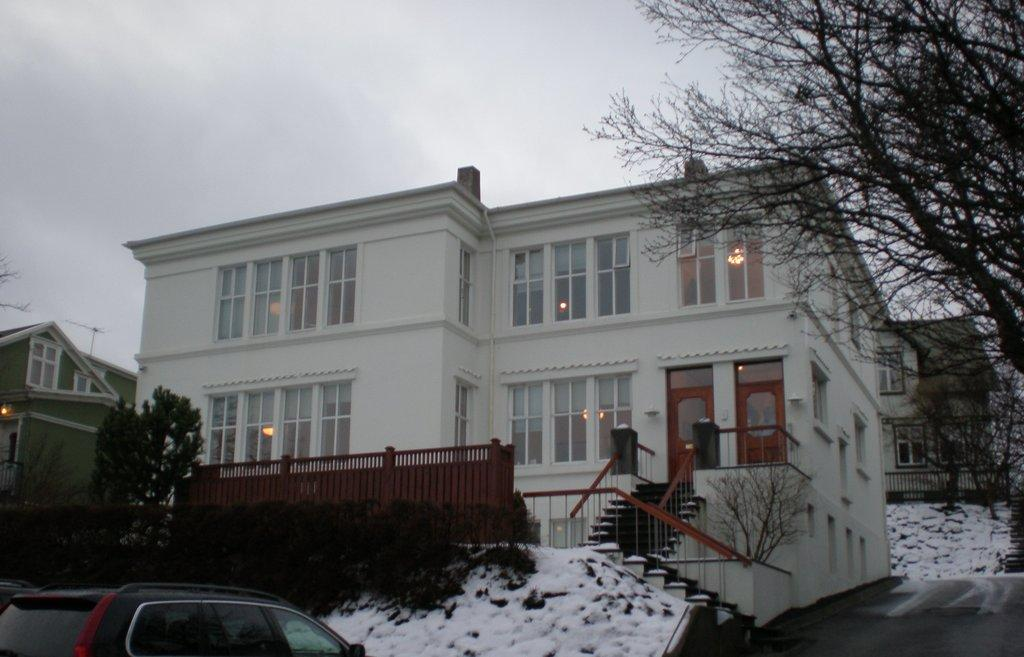How many buildings can be seen in the image? There are three buildings in the image. What else is present in the image besides the buildings? There are trees, a staircase, a car, and clouds visible in the sky at the top of the image. What type of punishment is being handed out in the image? There is no indication of punishment in the image; it features three buildings, trees, a staircase, a car, and clouds. 